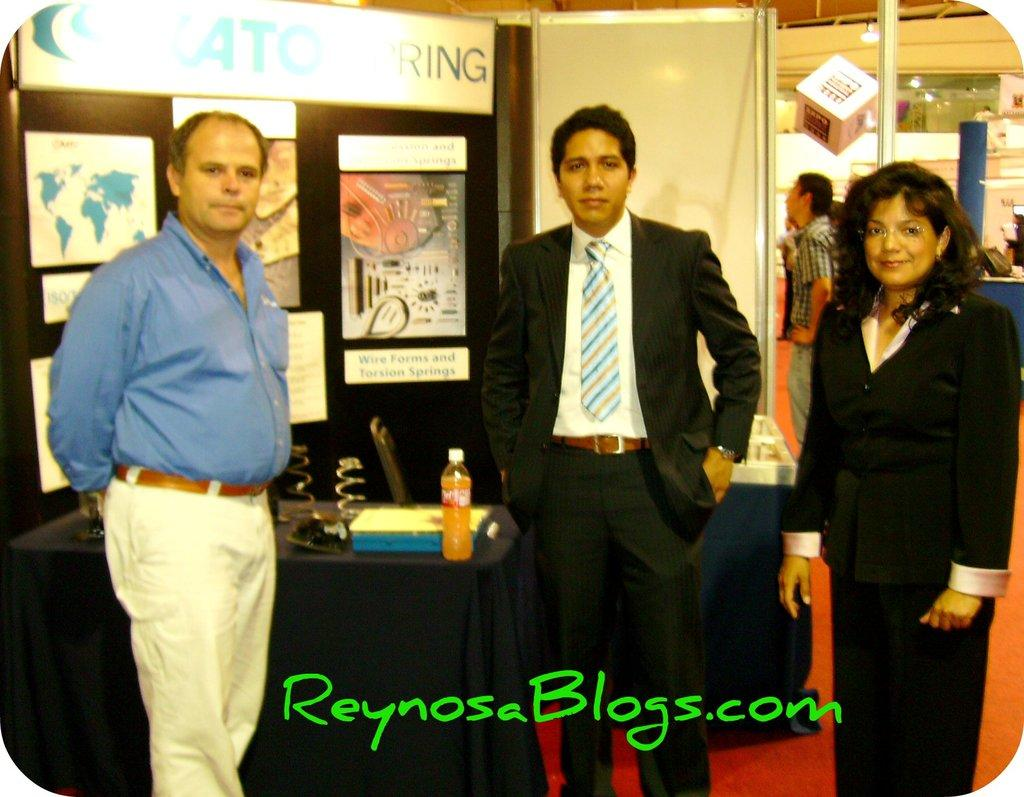What type of structure can be seen in the image? There is a wall in the image. What decorations are present in the image? There are banners in the image. Who or what is present in the image? There are people in the image. What type of furniture is in the image? There is a chair and a table in the image. What items are on the table? There is a tray and a bottle on the table. What color is the silver rain in the image? There is no silver rain present in the image. How does the water affect the people in the image? There is no water present in the image, so it does not affect the people. 